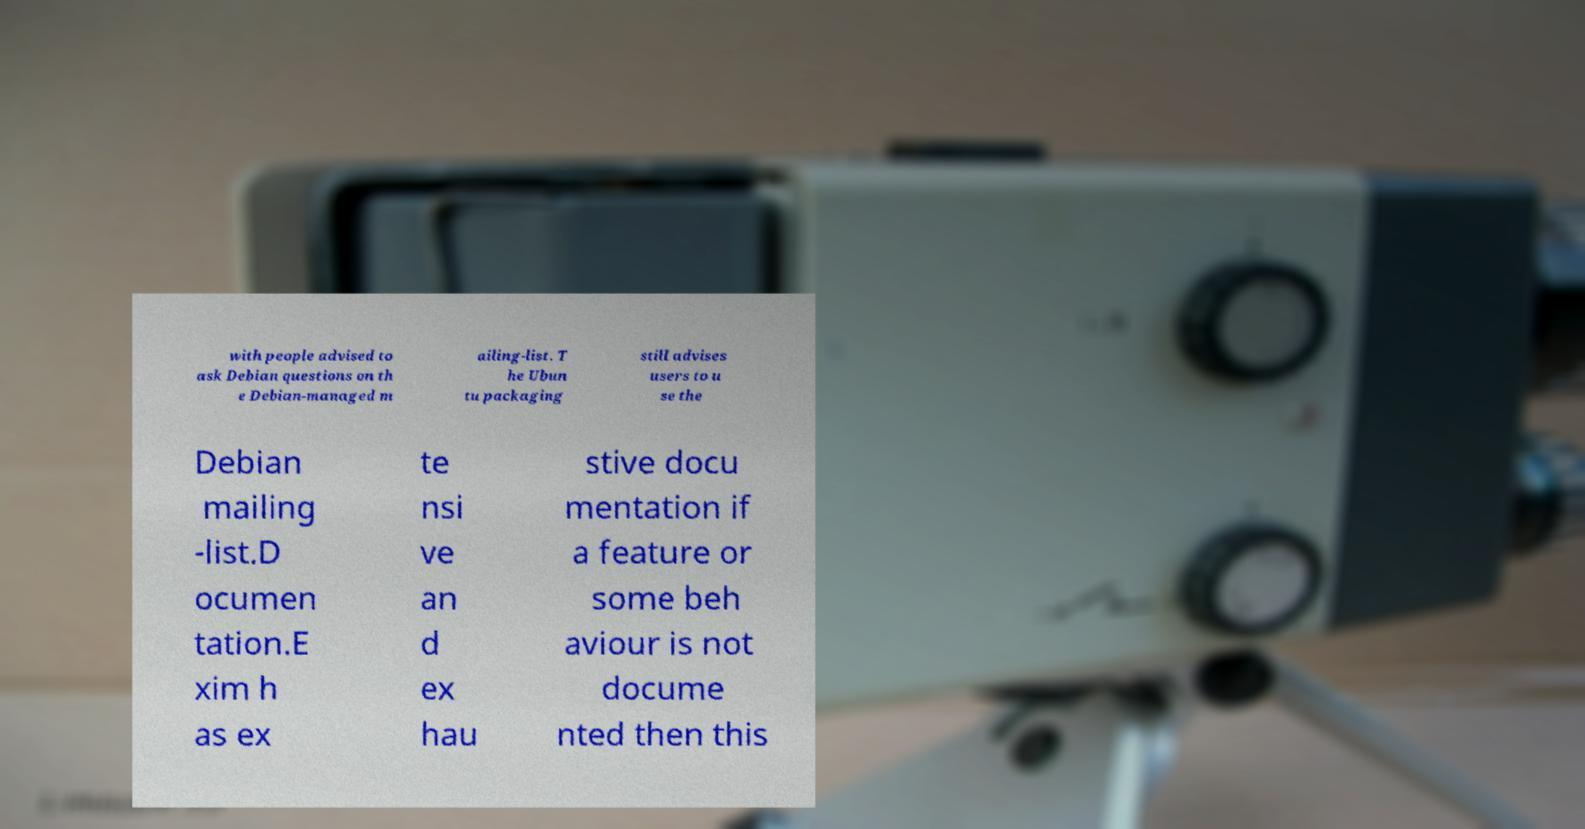Could you assist in decoding the text presented in this image and type it out clearly? with people advised to ask Debian questions on th e Debian-managed m ailing-list. T he Ubun tu packaging still advises users to u se the Debian mailing -list.D ocumen tation.E xim h as ex te nsi ve an d ex hau stive docu mentation if a feature or some beh aviour is not docume nted then this 